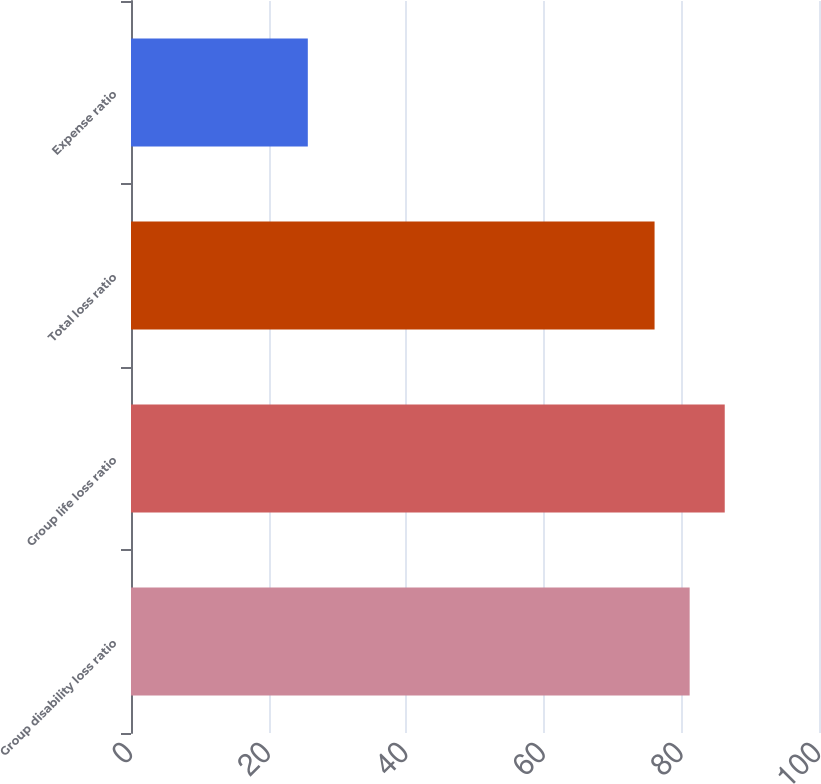<chart> <loc_0><loc_0><loc_500><loc_500><bar_chart><fcel>Group disability loss ratio<fcel>Group life loss ratio<fcel>Total loss ratio<fcel>Expense ratio<nl><fcel>81.2<fcel>86.3<fcel>76.1<fcel>25.7<nl></chart> 